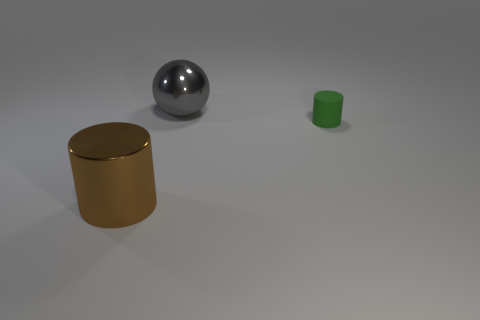If these objects were part of a larger set, what other items might you expect to see? If these objects were part of a larger set, it might be a collection demonstrating shapes and materials. In such a set, one might expect to see additional geometric shapes like cones, cubes, or pyramids, possibly in various materials like glass, wood, or different types of plastic. The aim of such a set could be educational, showing how light interacts with surfaces, or simply an artistic display of form and texture. 